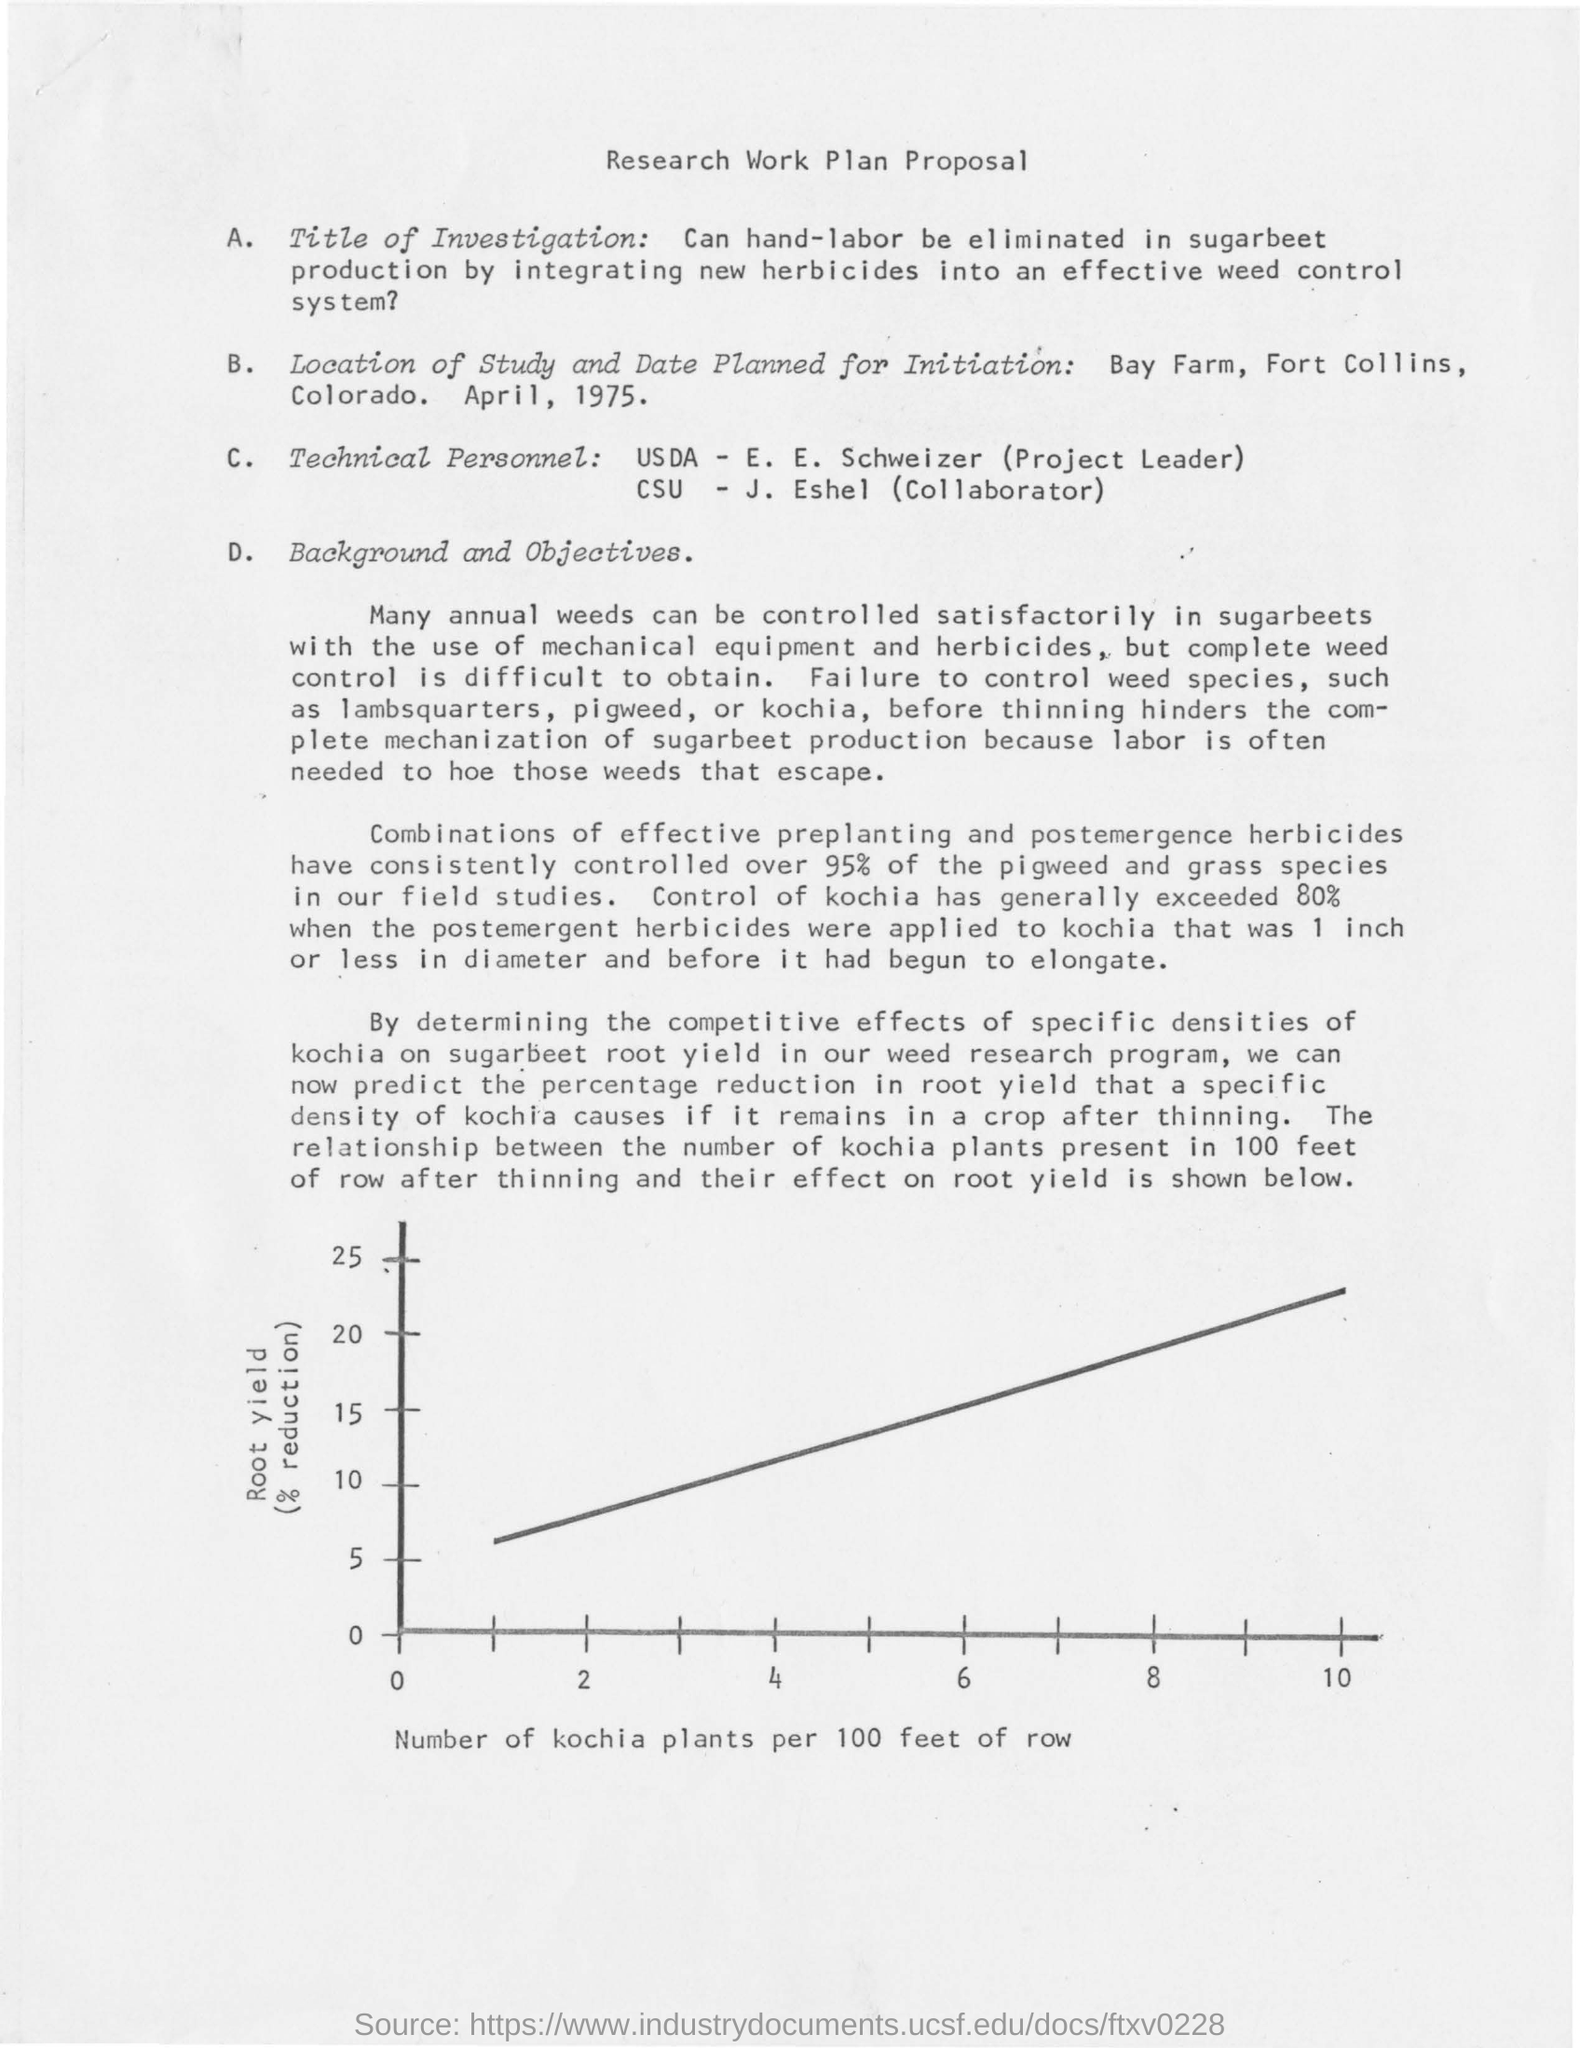List a handful of essential elements in this visual. The location of the study is Bay Farm and Fort Collins, Colorado. The x-axis of the graph represents the number of Kochia plants per 100 feet of row. 